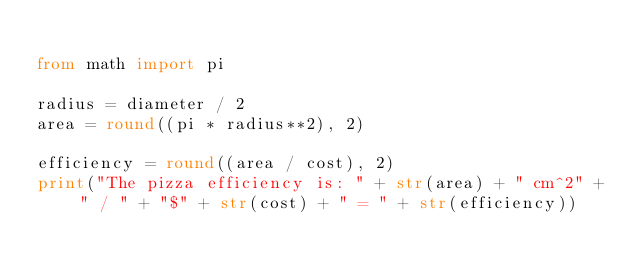<code> <loc_0><loc_0><loc_500><loc_500><_Python_>
from math import pi

radius = diameter / 2
area = round((pi * radius**2), 2)

efficiency = round((area / cost), 2)
print("The pizza efficiency is: " + str(area) + " cm^2" + " / " + "$" + str(cost) + " = " + str(efficiency))
</code> 